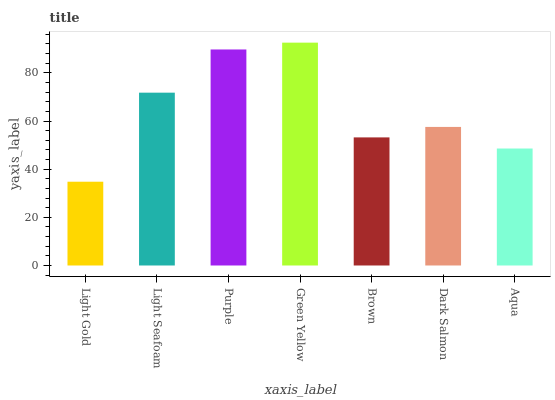Is Light Gold the minimum?
Answer yes or no. Yes. Is Green Yellow the maximum?
Answer yes or no. Yes. Is Light Seafoam the minimum?
Answer yes or no. No. Is Light Seafoam the maximum?
Answer yes or no. No. Is Light Seafoam greater than Light Gold?
Answer yes or no. Yes. Is Light Gold less than Light Seafoam?
Answer yes or no. Yes. Is Light Gold greater than Light Seafoam?
Answer yes or no. No. Is Light Seafoam less than Light Gold?
Answer yes or no. No. Is Dark Salmon the high median?
Answer yes or no. Yes. Is Dark Salmon the low median?
Answer yes or no. Yes. Is Light Gold the high median?
Answer yes or no. No. Is Aqua the low median?
Answer yes or no. No. 